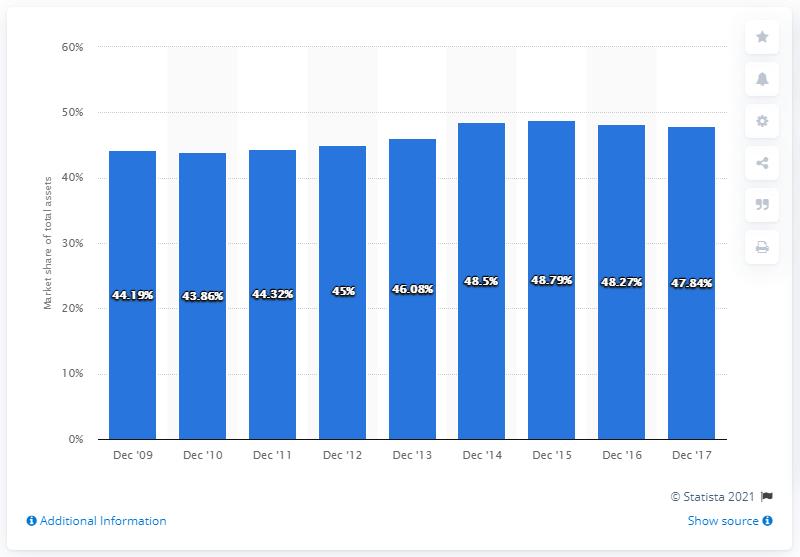Give some essential details in this illustration. The market share of the top five banks in Poland between 2009 and 2015 was 48.79%. The control over assets of the top five banks in Poland decreased by 48.79% between 2009 and 2017. 